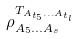<formula> <loc_0><loc_0><loc_500><loc_500>\rho _ { A _ { 5 } \dots A _ { s } } ^ { T _ { A _ { t _ { 5 } } \dots A _ { t _ { l } } } }</formula> 